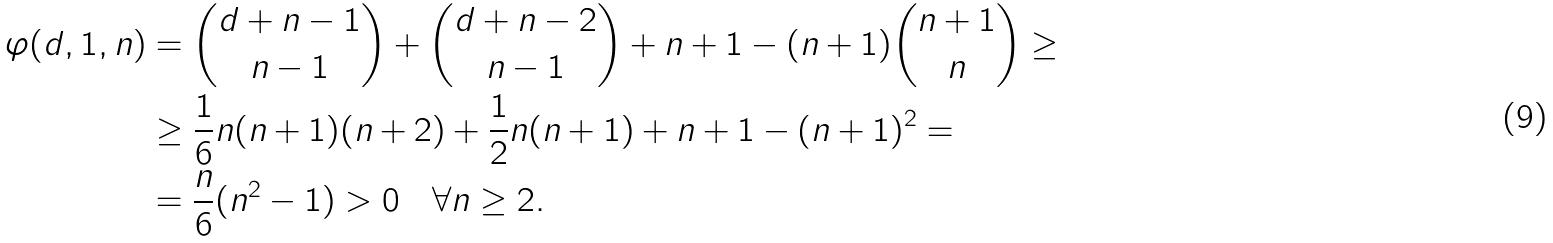<formula> <loc_0><loc_0><loc_500><loc_500>\varphi ( d , 1 , n ) & = \binom { d + n - 1 } { n - 1 } + \binom { d + n - 2 } { n - 1 } + n + 1 - ( n + 1 ) \binom { n + 1 } { n } \geq \\ & \geq \frac { 1 } { 6 } n ( n + 1 ) ( n + 2 ) + \frac { 1 } { 2 } n ( n + 1 ) + n + 1 - ( n + 1 ) ^ { 2 } = \\ & = \frac { n } { 6 } ( n ^ { 2 } - 1 ) > 0 \quad \forall n \geq 2 .</formula> 